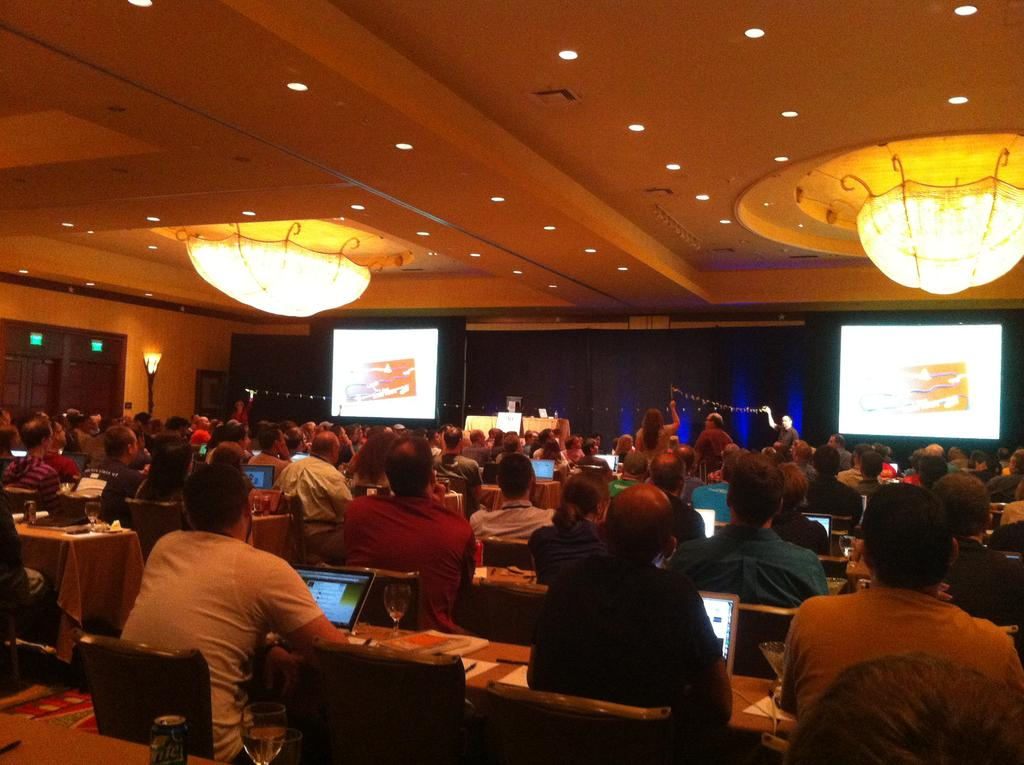Who or what can be seen in the image? There are people in the image. What are the people doing in the image? The people are sitting on chairs. What objects are present on the table in the image? There are laptops on the table. What type of veil can be seen covering the laptops in the image? There is no veil present in the image, and the laptops are not covered. Is there any evidence of a battle taking place in the image? There is no indication of a battle or any conflict in the image. 